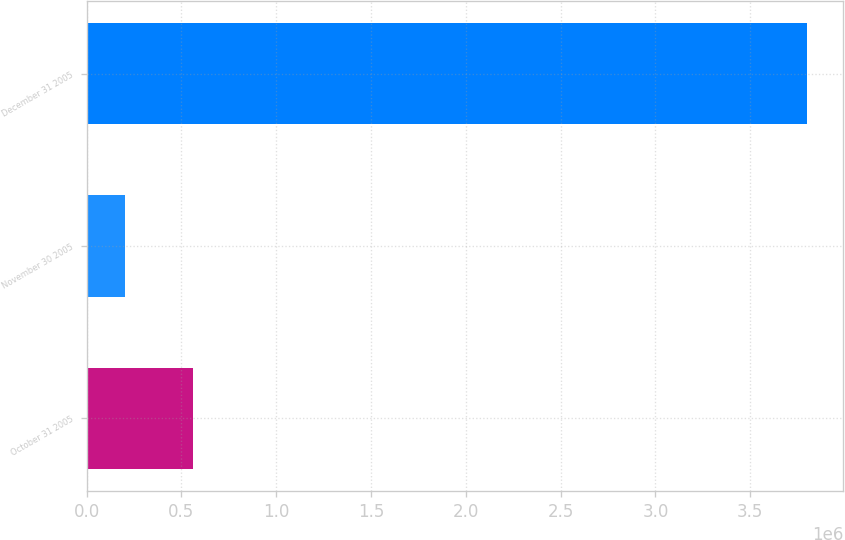Convert chart. <chart><loc_0><loc_0><loc_500><loc_500><bar_chart><fcel>October 31 2005<fcel>November 30 2005<fcel>December 31 2005<nl><fcel>560000<fcel>200000<fcel>3.8e+06<nl></chart> 